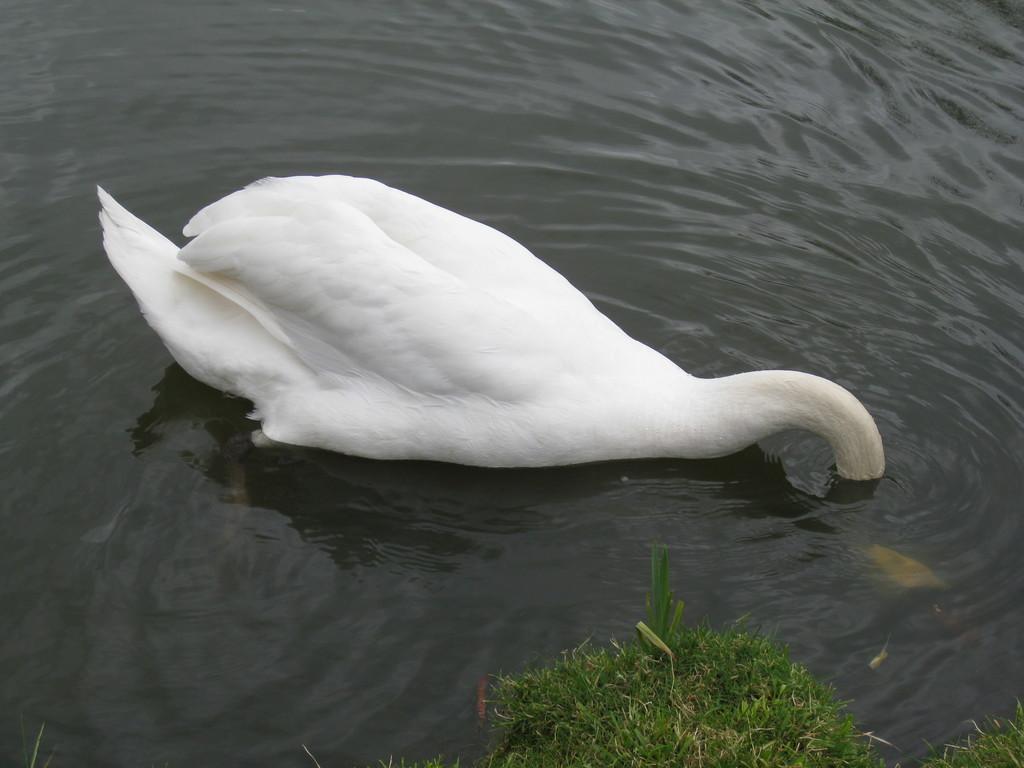Describe this image in one or two sentences. This picture contains a swan. It is white in color. It might be swimming in the water or might be drinking the water. This water might be in the pond. At the bottom of the picture, we see the grass. 